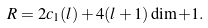<formula> <loc_0><loc_0><loc_500><loc_500>R = 2 c _ { 1 } ( l ) + 4 ( l + 1 ) \dim + 1 .</formula> 